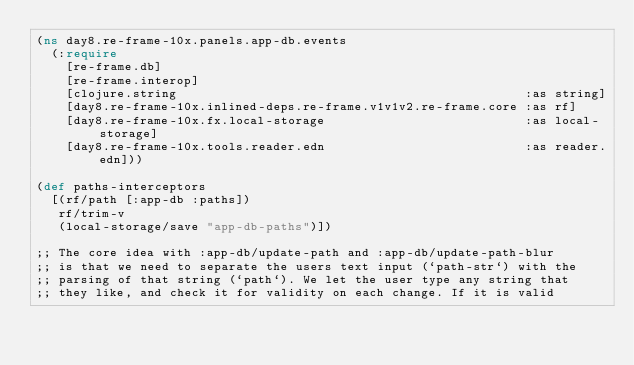<code> <loc_0><loc_0><loc_500><loc_500><_Clojure_>(ns day8.re-frame-10x.panels.app-db.events
  (:require
    [re-frame.db]
    [re-frame.interop]
    [clojure.string                                               :as string]
    [day8.re-frame-10x.inlined-deps.re-frame.v1v1v2.re-frame.core :as rf]
    [day8.re-frame-10x.fx.local-storage                           :as local-storage]
    [day8.re-frame-10x.tools.reader.edn                           :as reader.edn]))

(def paths-interceptors
  [(rf/path [:app-db :paths])
   rf/trim-v
   (local-storage/save "app-db-paths")])

;; The core idea with :app-db/update-path and :app-db/update-path-blur
;; is that we need to separate the users text input (`path-str`) with the
;; parsing of that string (`path`). We let the user type any string that
;; they like, and check it for validity on each change. If it is valid</code> 